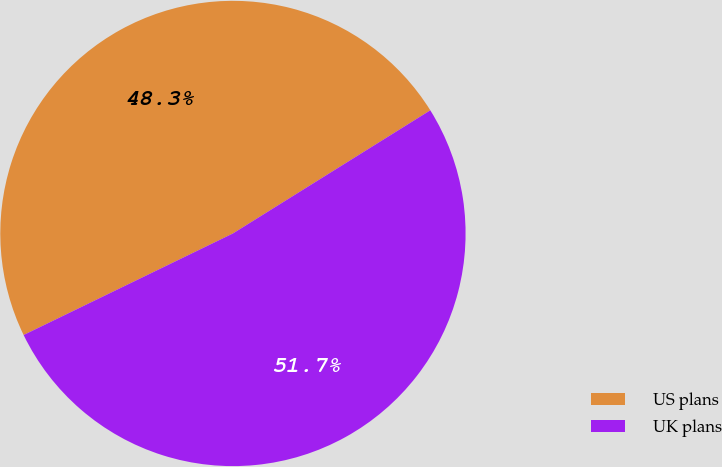Convert chart. <chart><loc_0><loc_0><loc_500><loc_500><pie_chart><fcel>US plans<fcel>UK plans<nl><fcel>48.31%<fcel>51.69%<nl></chart> 